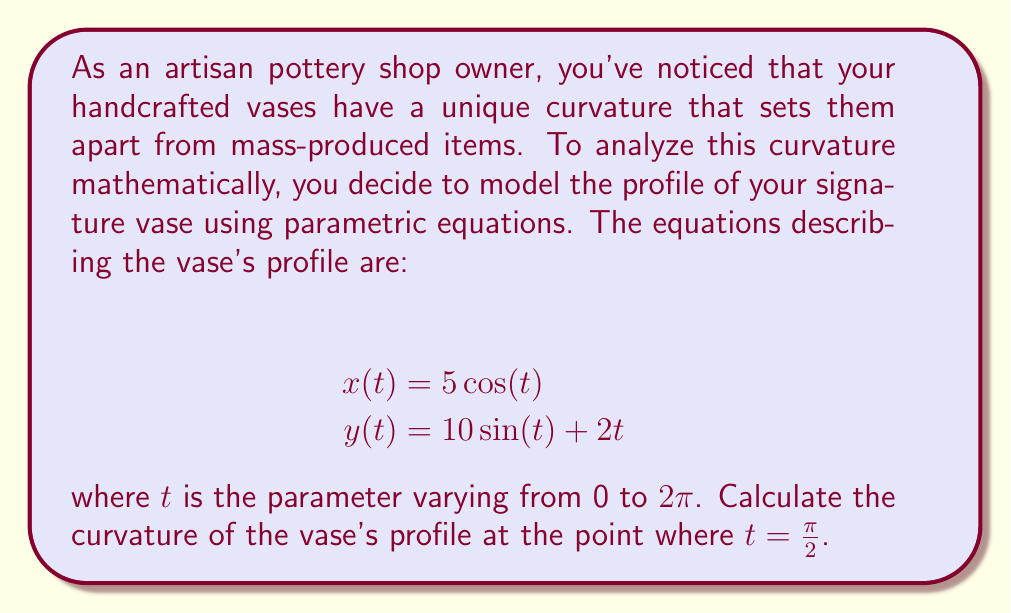Help me with this question. To solve this problem, we'll follow these steps:

1) Recall the formula for curvature in parametric form:

   $$\kappa = \frac{|x'y'' - y'x''|}{(x'^2 + y'^2)^{3/2}}$$

2) Calculate the first and second derivatives of $x(t)$ and $y(t)$:

   $$x'(t) = -5\sin(t)$$
   $$x''(t) = -5\cos(t)$$
   $$y'(t) = 10\cos(t) + 2$$
   $$y''(t) = -10\sin(t)$$

3) Evaluate these at $t = \frac{\pi}{2}$:

   $$x'(\frac{\pi}{2}) = -5$$
   $$x''(\frac{\pi}{2}) = 0$$
   $$y'(\frac{\pi}{2}) = 2$$
   $$y''(\frac{\pi}{2}) = -10$$

4) Substitute these values into the curvature formula:

   $$\kappa = \frac{|(-5)(-10) - (2)(0)|}{((-5)^2 + 2^2)^{3/2}}$$

5) Simplify:

   $$\kappa = \frac{50}{(25 + 4)^{3/2}} = \frac{50}{29^{3/2}}$$

6) This can be further simplified to:

   $$\kappa = \frac{50}{29\sqrt{29}}$$

This is the curvature of the vase's profile at the point where $t = \frac{\pi}{2}$.
Answer: $\kappa = \frac{50}{29\sqrt{29}}$ 